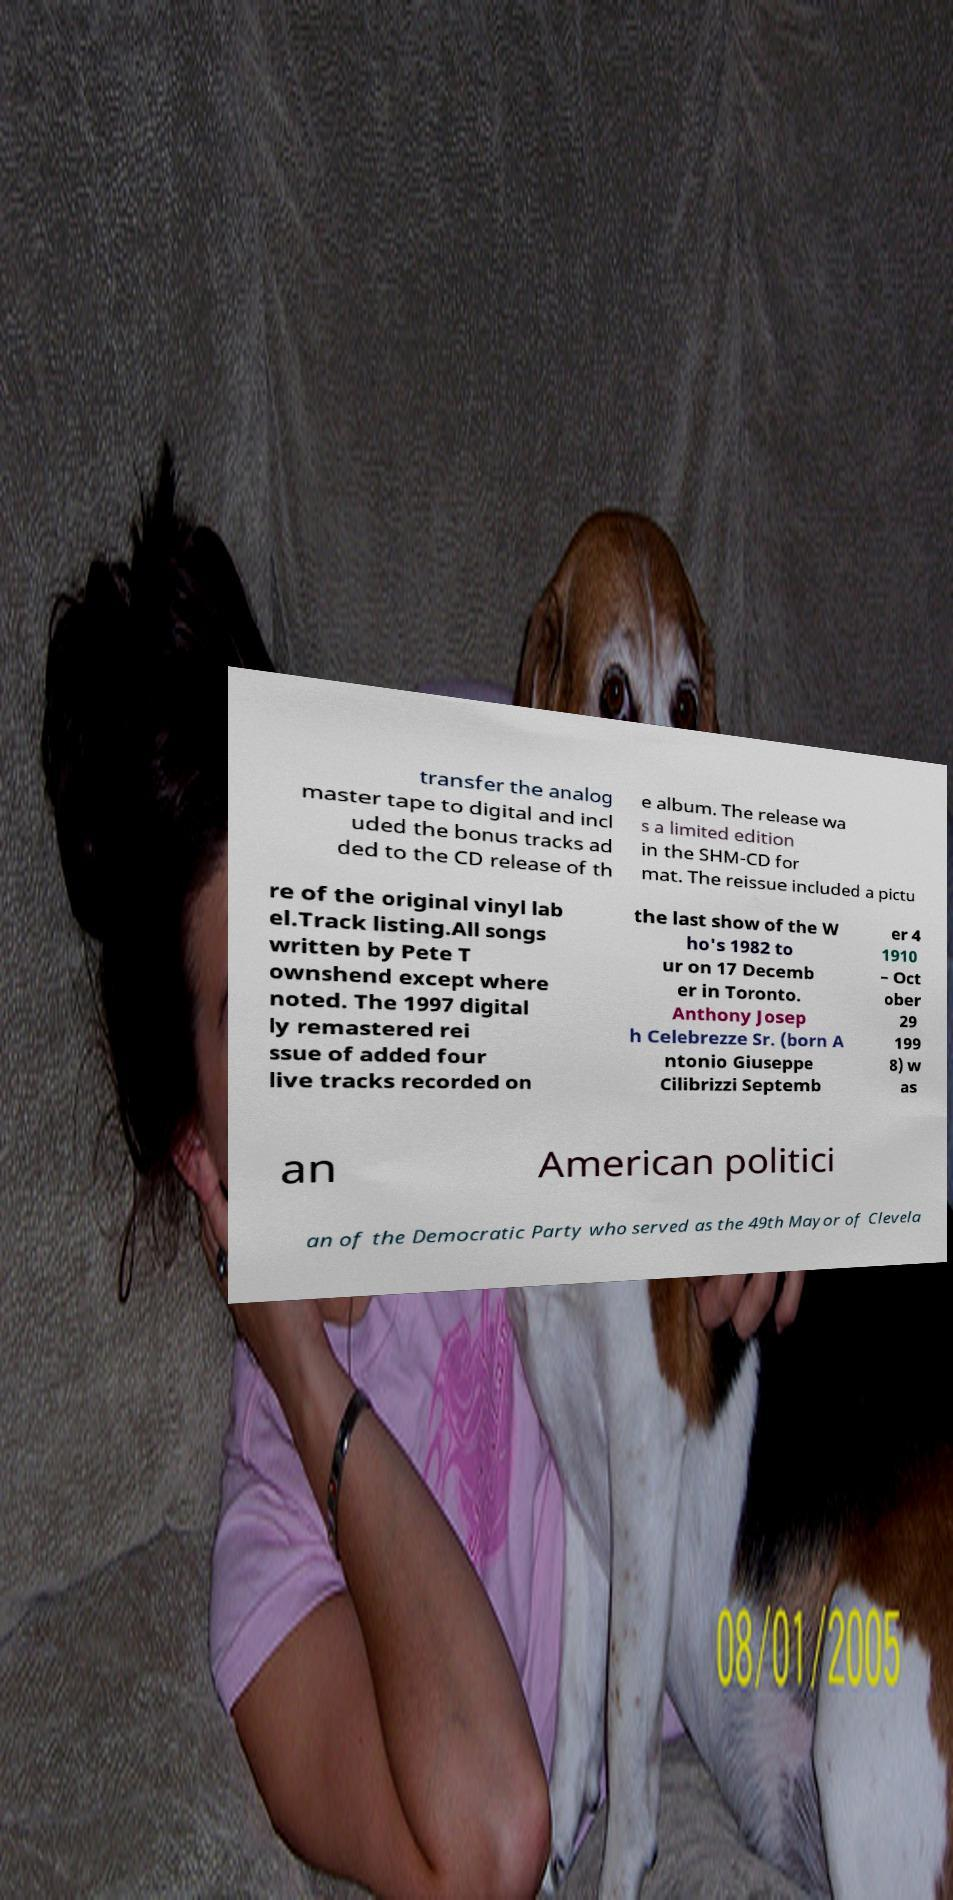Could you assist in decoding the text presented in this image and type it out clearly? transfer the analog master tape to digital and incl uded the bonus tracks ad ded to the CD release of th e album. The release wa s a limited edition in the SHM-CD for mat. The reissue included a pictu re of the original vinyl lab el.Track listing.All songs written by Pete T ownshend except where noted. The 1997 digital ly remastered rei ssue of added four live tracks recorded on the last show of the W ho's 1982 to ur on 17 Decemb er in Toronto. Anthony Josep h Celebrezze Sr. (born A ntonio Giuseppe Cilibrizzi Septemb er 4 1910 – Oct ober 29 199 8) w as an American politici an of the Democratic Party who served as the 49th Mayor of Clevela 